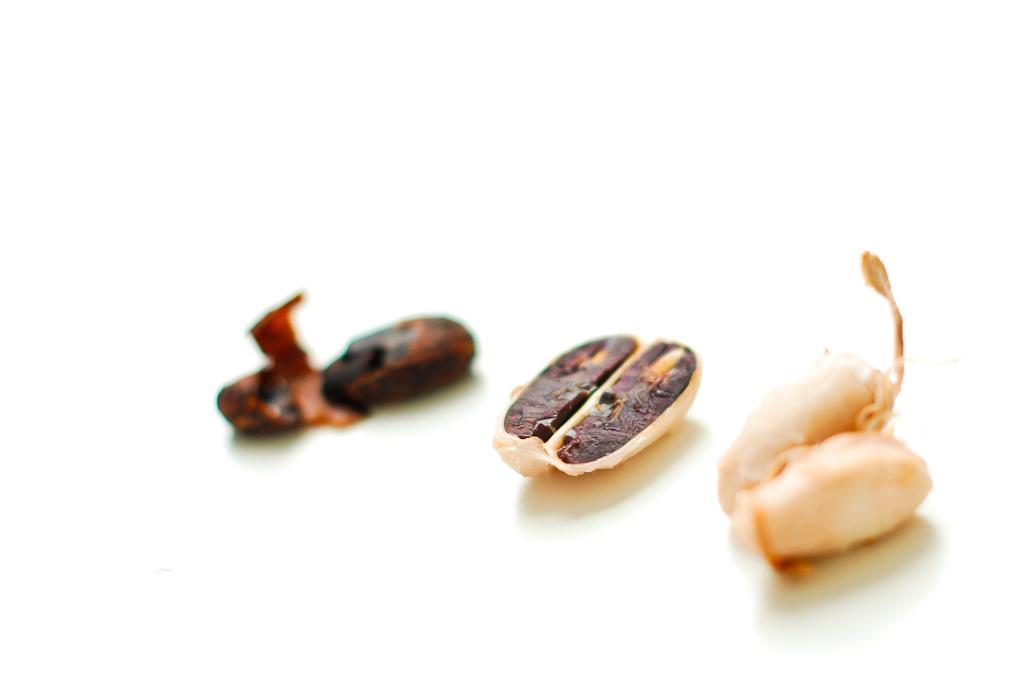What type of small objects can be seen in the image? There are seeds in the image. What type of laborer is shown working with the seeds in the image? There is no laborer present in the image; it only shows seeds. Can you tell me how fast the pet is running in the image? There is no pet present in the image, so it is not possible to determine the speed at which it might be running. 